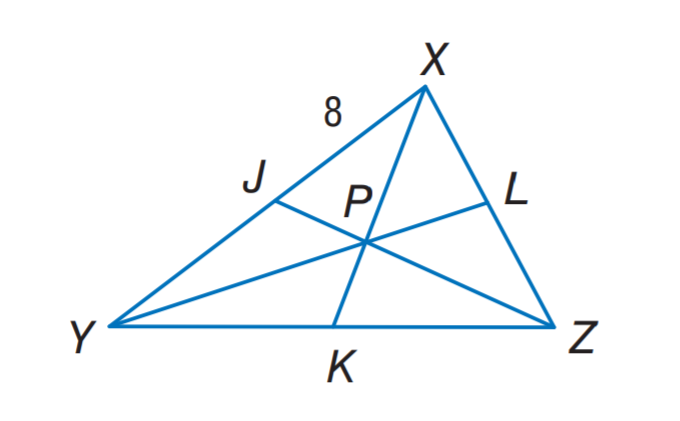Question: in \triangle X Y Z, P is the centroid, K P = 3, and X J = 8. Find X K.
Choices:
A. 3
B. 6
C. 8
D. 9
Answer with the letter. Answer: D 